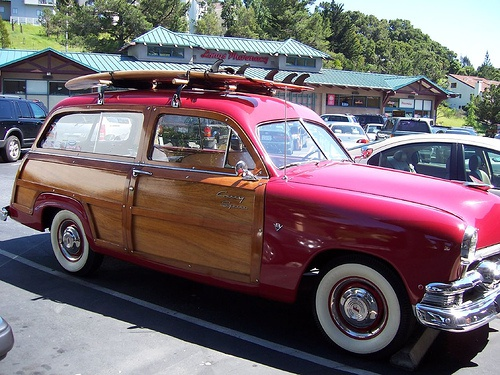Describe the objects in this image and their specific colors. I can see car in darkblue, maroon, black, lavender, and gray tones, car in darkblue, navy, white, and gray tones, surfboard in darkblue, black, maroon, white, and gray tones, car in darkblue, black, blue, and gray tones, and car in darkblue, navy, gray, and white tones in this image. 